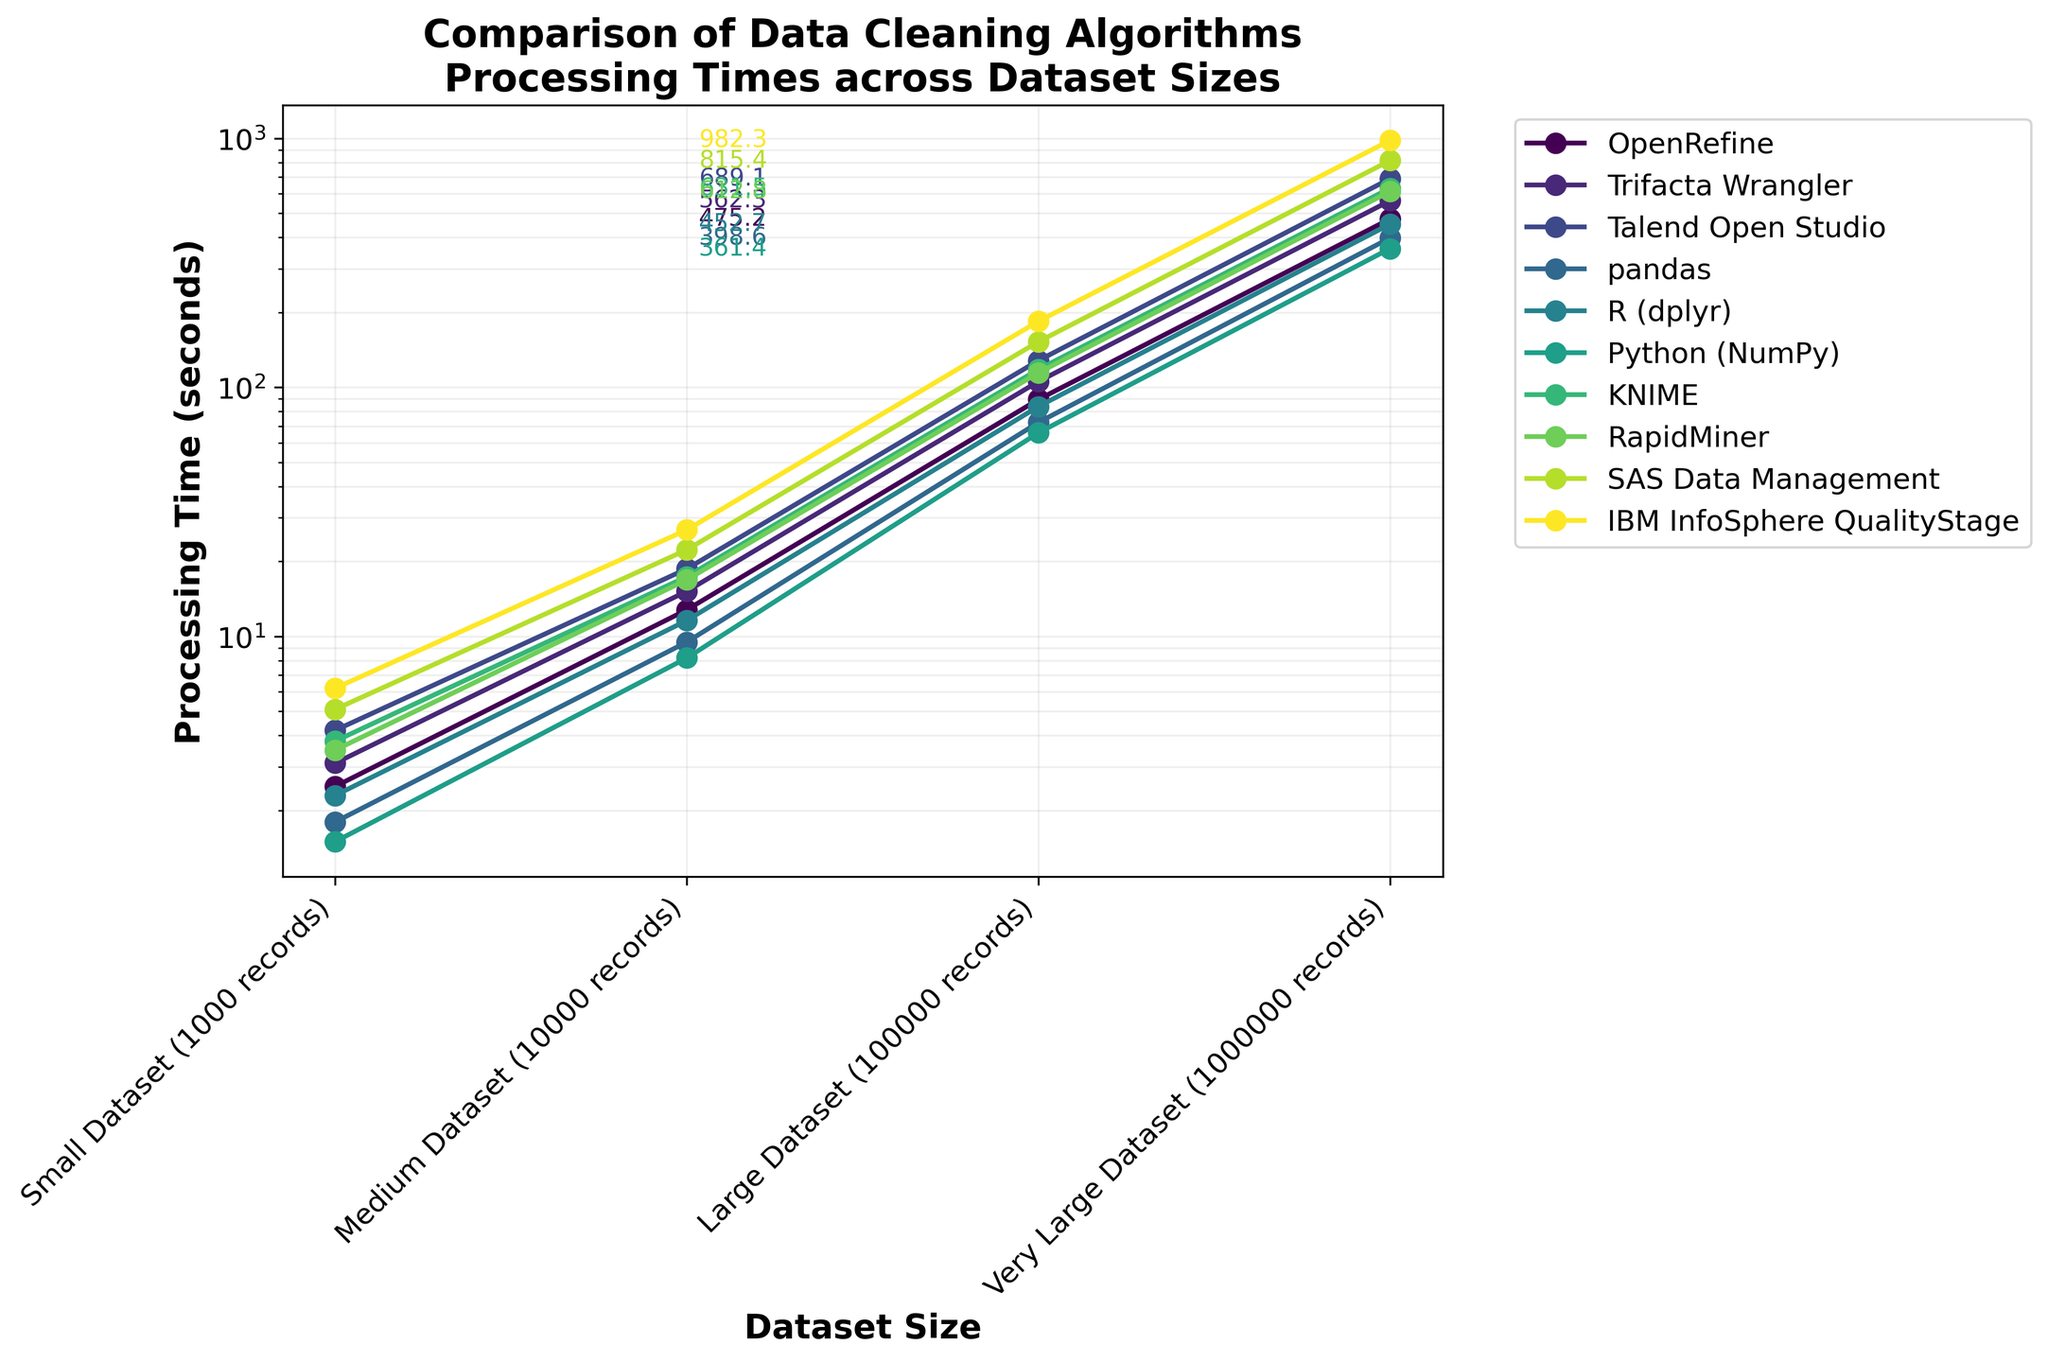Which algorithm has the lowest processing time across all dataset sizes? Looking at the lines in the plot, the algorithm with the lowest processing time at each dataset size is represented by the lowest position on the y-axis. Python (NumPy) has the lowest values across all dataset sizes.
Answer: Python (NumPy) How does the processing time of OpenRefine compare to pandas for a Very Large Dataset? Find the points on the line for OpenRefine and pandas at the Very Large Dataset size. OpenRefine's processing time (~475.2 seconds) is higher than pandas' (~398.6 seconds).
Answer: OpenRefine is slower than pandas Which two algorithms have the most similar processing times for a Medium Dataset? Observe the points on the Medium Dataset to see which lines are closest to each other. OpenRefine (~12.8 seconds) and R (dplyr) (~11.6 seconds) are closest.
Answer: OpenRefine and R (dplyr) What is the difference in processing times between Talend Open Studio and KNIME for a Large Dataset? Find the processing times for Talend Open Studio (~128.3 seconds) and KNIME (~118.2 seconds) for a Large Dataset and subtract the smaller value from the larger value. The difference is 10.1 seconds.
Answer: 10.1 seconds Which algorithm shows the steepest increase in processing time from a Small Dataset to a Very Large Dataset? The steepest increase will be the line with the greatest vertical change. IBM InfoSphere QualityStage shows the steepest increase visually.
Answer: IBM InfoSphere QualityStage For the Small Dataset, how does the average processing time of all algorithms compare with the processing time of SAS Data Management? Calculate the average processing time for all algorithms for the Small Dataset: (2.5 + 3.1 + 4.2 + 1.8 + 2.3 + 1.5 + 3.8 + 3.5 + 5.1 + 6.2) / 10 = 3.4 seconds. Compare this average with SAS Data Management (5.1 seconds). SAS Data Management is slower.
Answer: SAS Data Management is slower Which algorithm has the largest overall variance in processing time across different dataset sizes? Variance can be estimated by looking at the spread of the points for each algorithm's line. IBM InfoSphere QualityStage has the widest spread, indicating the largest variance.
Answer: IBM InfoSphere QualityStage Considering the Medium and Large Datasets, which algorithm shows a more than tenfold increase in processing time? Identify the processing times for Medium and Large Datasets for each algorithm and check if the ratio of Large to Medium processing times exceeds 10. No algorithms exhibit a more than tenfold increase.
Answer: None 